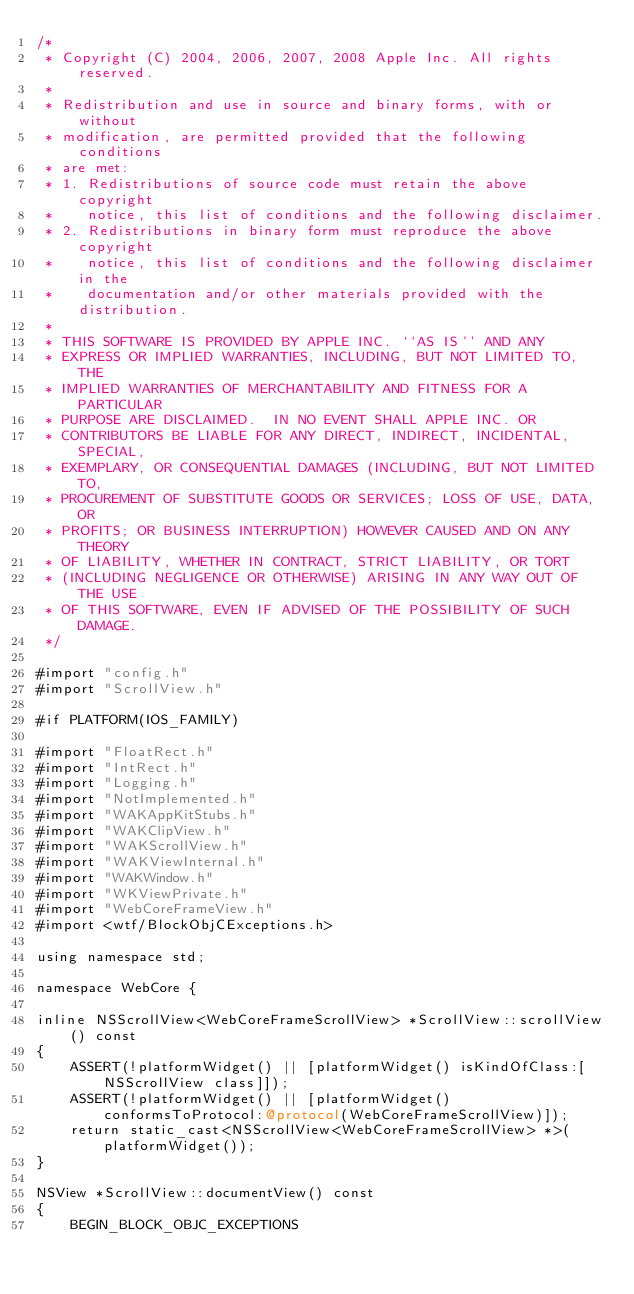Convert code to text. <code><loc_0><loc_0><loc_500><loc_500><_ObjectiveC_>/*
 * Copyright (C) 2004, 2006, 2007, 2008 Apple Inc. All rights reserved.
 *
 * Redistribution and use in source and binary forms, with or without
 * modification, are permitted provided that the following conditions
 * are met:
 * 1. Redistributions of source code must retain the above copyright
 *    notice, this list of conditions and the following disclaimer.
 * 2. Redistributions in binary form must reproduce the above copyright
 *    notice, this list of conditions and the following disclaimer in the
 *    documentation and/or other materials provided with the distribution.
 *
 * THIS SOFTWARE IS PROVIDED BY APPLE INC. ``AS IS'' AND ANY
 * EXPRESS OR IMPLIED WARRANTIES, INCLUDING, BUT NOT LIMITED TO, THE
 * IMPLIED WARRANTIES OF MERCHANTABILITY AND FITNESS FOR A PARTICULAR
 * PURPOSE ARE DISCLAIMED.  IN NO EVENT SHALL APPLE INC. OR
 * CONTRIBUTORS BE LIABLE FOR ANY DIRECT, INDIRECT, INCIDENTAL, SPECIAL,
 * EXEMPLARY, OR CONSEQUENTIAL DAMAGES (INCLUDING, BUT NOT LIMITED TO,
 * PROCUREMENT OF SUBSTITUTE GOODS OR SERVICES; LOSS OF USE, DATA, OR
 * PROFITS; OR BUSINESS INTERRUPTION) HOWEVER CAUSED AND ON ANY THEORY
 * OF LIABILITY, WHETHER IN CONTRACT, STRICT LIABILITY, OR TORT
 * (INCLUDING NEGLIGENCE OR OTHERWISE) ARISING IN ANY WAY OUT OF THE USE
 * OF THIS SOFTWARE, EVEN IF ADVISED OF THE POSSIBILITY OF SUCH DAMAGE. 
 */

#import "config.h"
#import "ScrollView.h"

#if PLATFORM(IOS_FAMILY)

#import "FloatRect.h"
#import "IntRect.h"
#import "Logging.h"
#import "NotImplemented.h"
#import "WAKAppKitStubs.h"
#import "WAKClipView.h"
#import "WAKScrollView.h"
#import "WAKViewInternal.h"
#import "WAKWindow.h"
#import "WKViewPrivate.h"
#import "WebCoreFrameView.h"
#import <wtf/BlockObjCExceptions.h>

using namespace std;

namespace WebCore {

inline NSScrollView<WebCoreFrameScrollView> *ScrollView::scrollView() const
{
    ASSERT(!platformWidget() || [platformWidget() isKindOfClass:[NSScrollView class]]);
    ASSERT(!platformWidget() || [platformWidget() conformsToProtocol:@protocol(WebCoreFrameScrollView)]);
    return static_cast<NSScrollView<WebCoreFrameScrollView> *>(platformWidget());
}

NSView *ScrollView::documentView() const
{
    BEGIN_BLOCK_OBJC_EXCEPTIONS</code> 